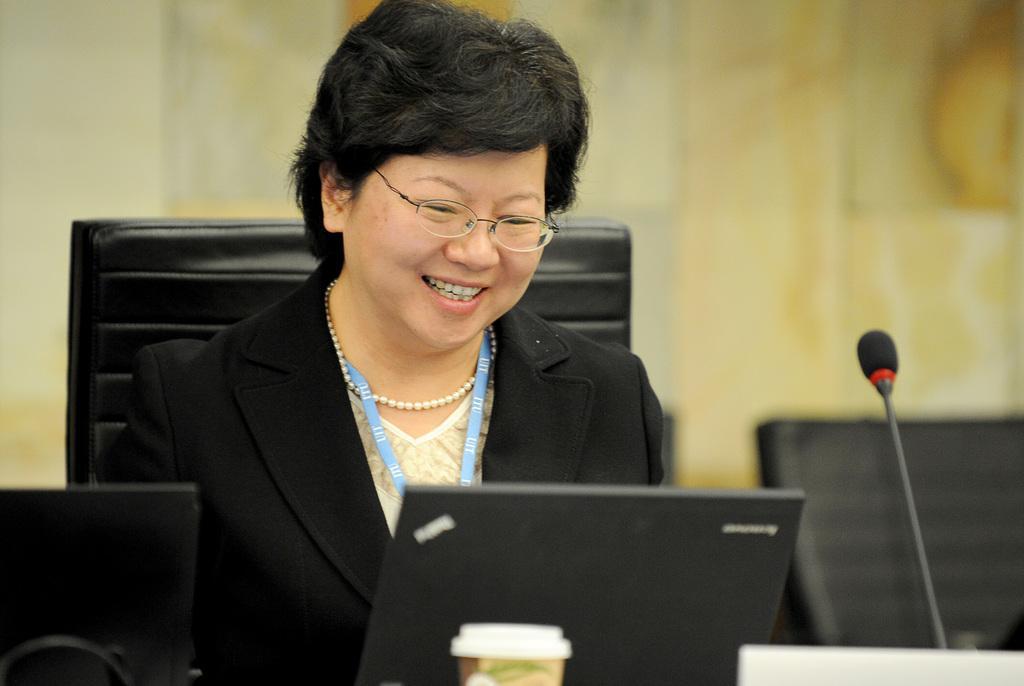Could you give a brief overview of what you see in this image? At the bottom of the image we can see some laptops and microphone and cup. Behind them a woman is sitting on a chair and smiling. Background of the image is blur. 